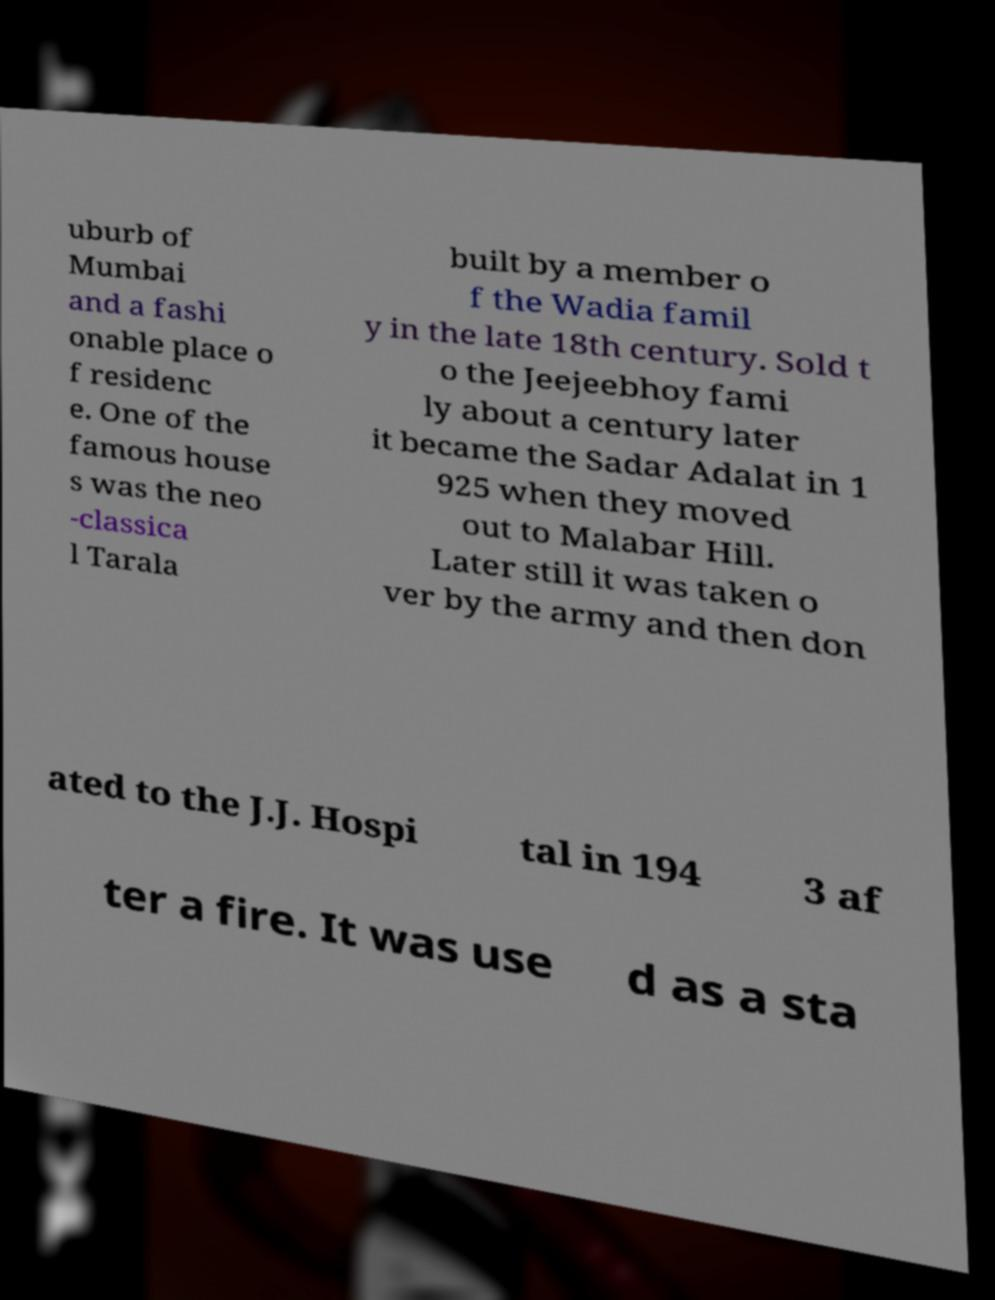I need the written content from this picture converted into text. Can you do that? uburb of Mumbai and a fashi onable place o f residenc e. One of the famous house s was the neo -classica l Tarala built by a member o f the Wadia famil y in the late 18th century. Sold t o the Jeejeebhoy fami ly about a century later it became the Sadar Adalat in 1 925 when they moved out to Malabar Hill. Later still it was taken o ver by the army and then don ated to the J.J. Hospi tal in 194 3 af ter a fire. It was use d as a sta 